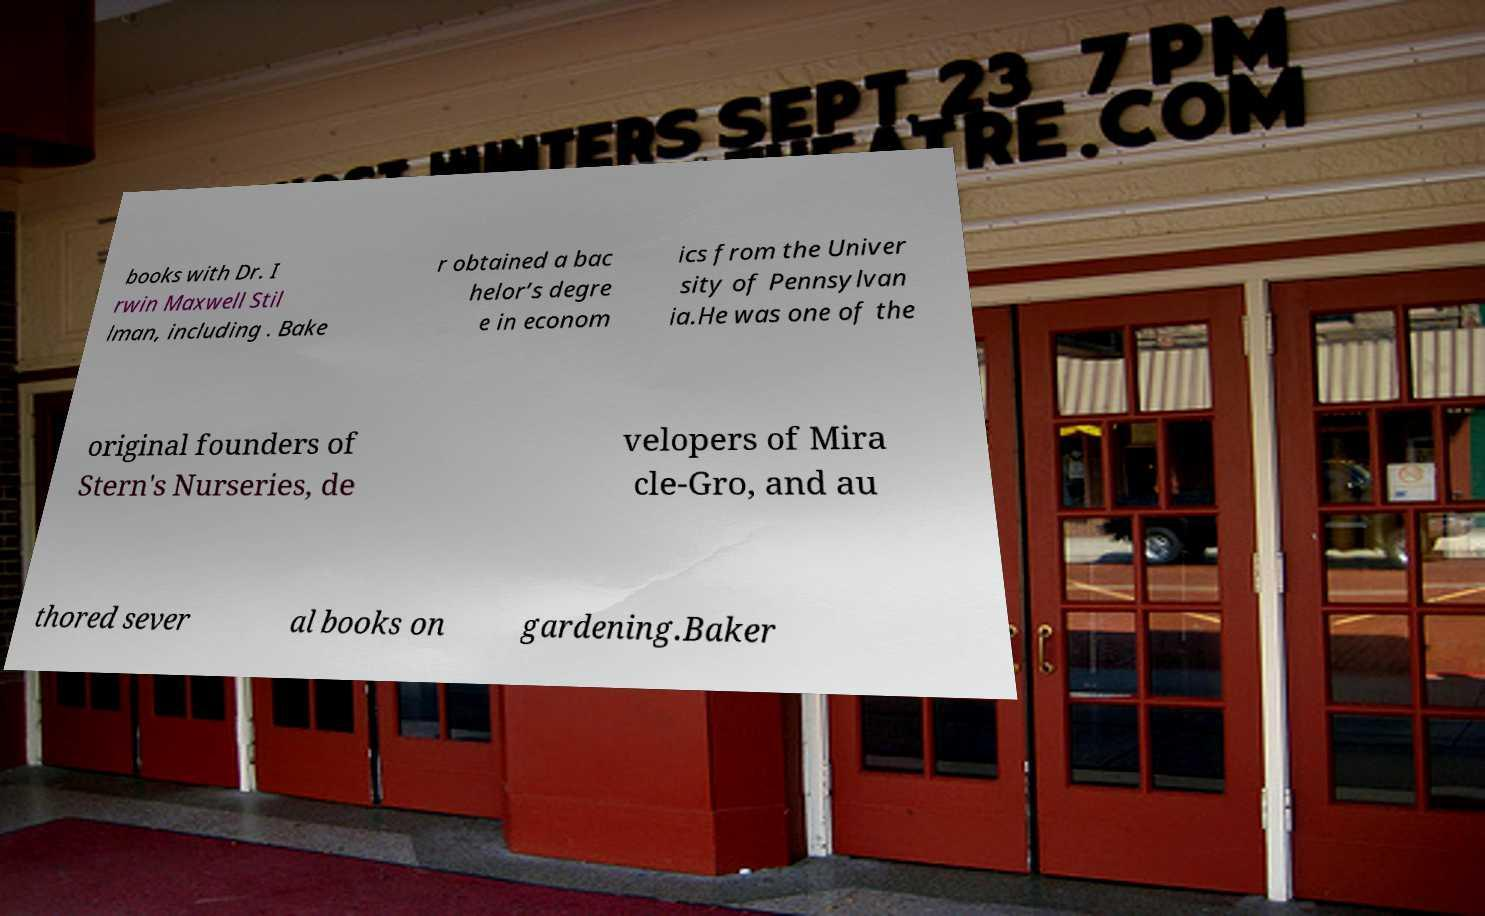Please identify and transcribe the text found in this image. books with Dr. I rwin Maxwell Stil lman, including . Bake r obtained a bac helor’s degre e in econom ics from the Univer sity of Pennsylvan ia.He was one of the original founders of Stern's Nurseries, de velopers of Mira cle-Gro, and au thored sever al books on gardening.Baker 